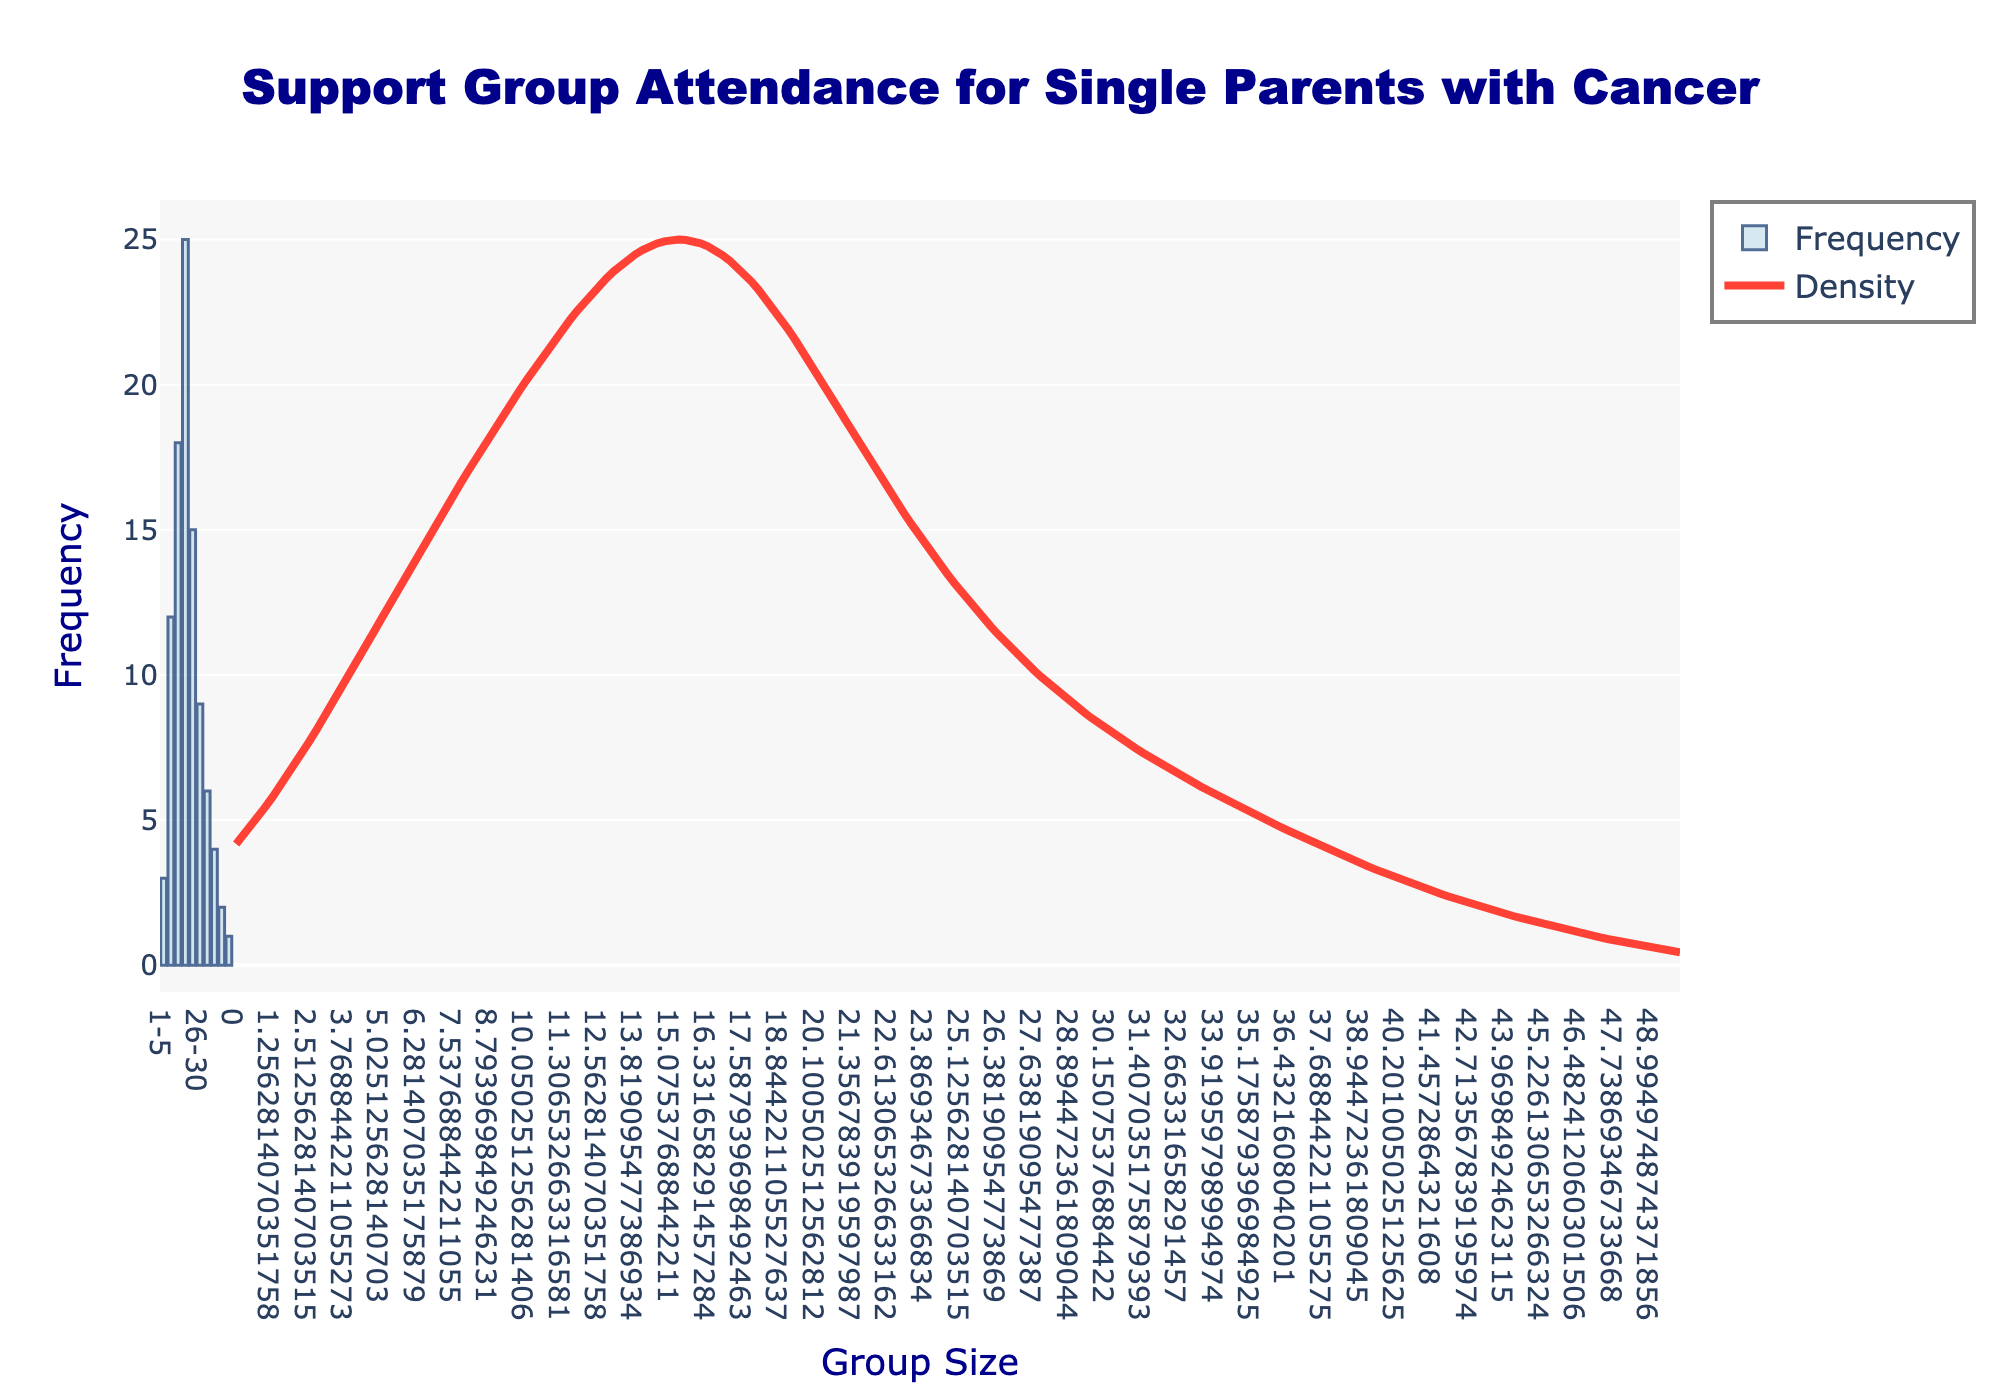Which group size has the highest frequency of support group attendance? The bar representing the 16-20 group size has the highest height in the histogram, which means it has the highest frequency of attendance.
Answer: 16-20 What is the title of the plot? The title of the plot is displayed at the top center of the image.
Answer: Support Group Attendance for Single Parents with Cancer What is the trend of the KDE curve as the group size increases? The KDE curve peaks around the group size of 18-25 and then gradually declines. This indicates that the density of the data is highest in this region and decreases as the group size increases beyond this range.
Answer: Peaks at 18-25 and then declines How many group sizes have a frequency of support group attendance equal to or greater than 10? By counting the bars with the height indicating frequency equal to or greater than 10, we find that there are three group sizes (6-10, 11-15, 16-20).
Answer: 3 Which group size category has the lowest frequency of support group attendance? The bar representing the 46-50 group size has the lowest height in the histogram, indicating the lowest frequency of attendance.
Answer: 46-50 What is the color of the bars in the histogram? The bars are primarily light blue with a dark blue border.
Answer: Light blue with a dark blue border Are there more groups with a frequency of 10 or greater compared to those with less than 10? By counting the groups, we find that there are 3 groups with frequencies of 10 or greater and 7 groups with frequencies less than 10. Therefore, there are more groups with frequencies less than 10.
Answer: No Which group sizes have a frequency exactly between 20 and 30? By observing the heights of the bars, the only groups with frequencies falling between 20 and 30 are the 16-20 group size.
Answer: 16-20 Compared to the 1-5 group size, how much higher is the attendance frequency in the 16-20 group size? By finding the difference in the heights of the bars, the attendance frequency of the 16-20 group (25) is 22 higher than the 1-5 group (3).
Answer: 22 